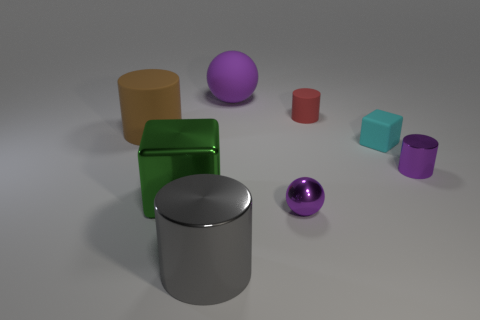Subtract 1 cylinders. How many cylinders are left? 3 Add 2 matte spheres. How many objects exist? 10 Subtract all blocks. How many objects are left? 6 Subtract all tiny gray matte blocks. Subtract all small rubber cubes. How many objects are left? 7 Add 2 small cylinders. How many small cylinders are left? 4 Add 7 gray shiny things. How many gray shiny things exist? 8 Subtract 0 red balls. How many objects are left? 8 